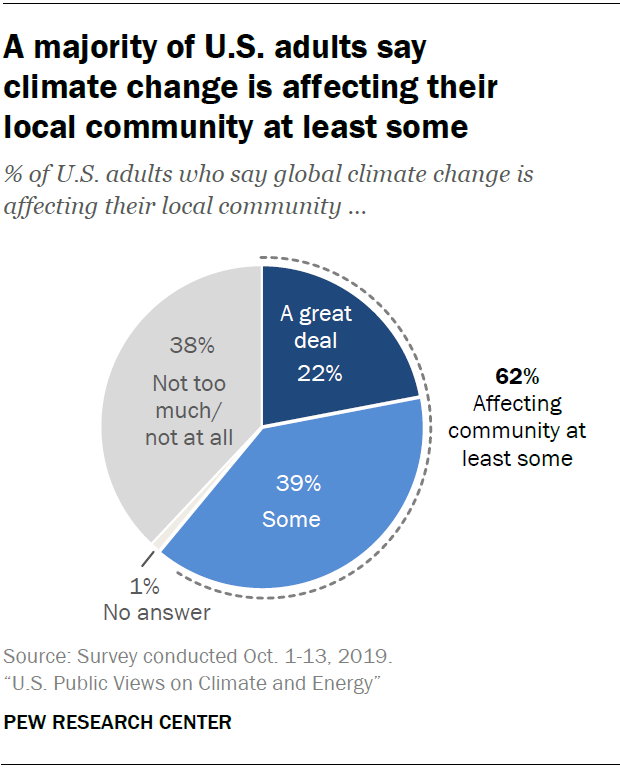Draw attention to some important aspects in this diagram. What is the sum of the two largest segments? The percentage value for the gray segment is 38. 